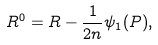<formula> <loc_0><loc_0><loc_500><loc_500>R ^ { 0 } = R - \frac { 1 } { 2 n } \psi _ { 1 } ( P ) ,</formula> 